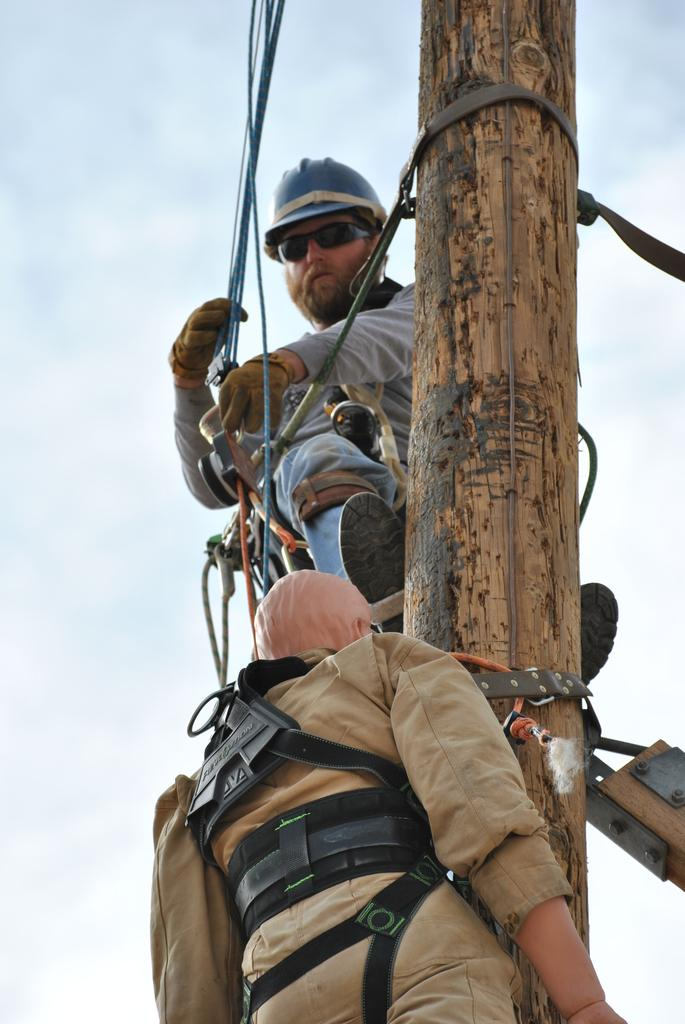How many people are in the image? There are two persons in the image. What are the persons doing in the image? The persons are climbing a pole. Can you describe the protective gear worn by one of the persons? One of the persons is wearing a helmet, goggles, and gloves. What can be seen in the background of the image? The sky is visible in the background of the image. Are the two persons in the image brothers? There is no information provided about the relationship between the two persons in the image. Can you tell me how much wealth the persons in the image have? There is no information provided about the wealth of the persons in the image. 